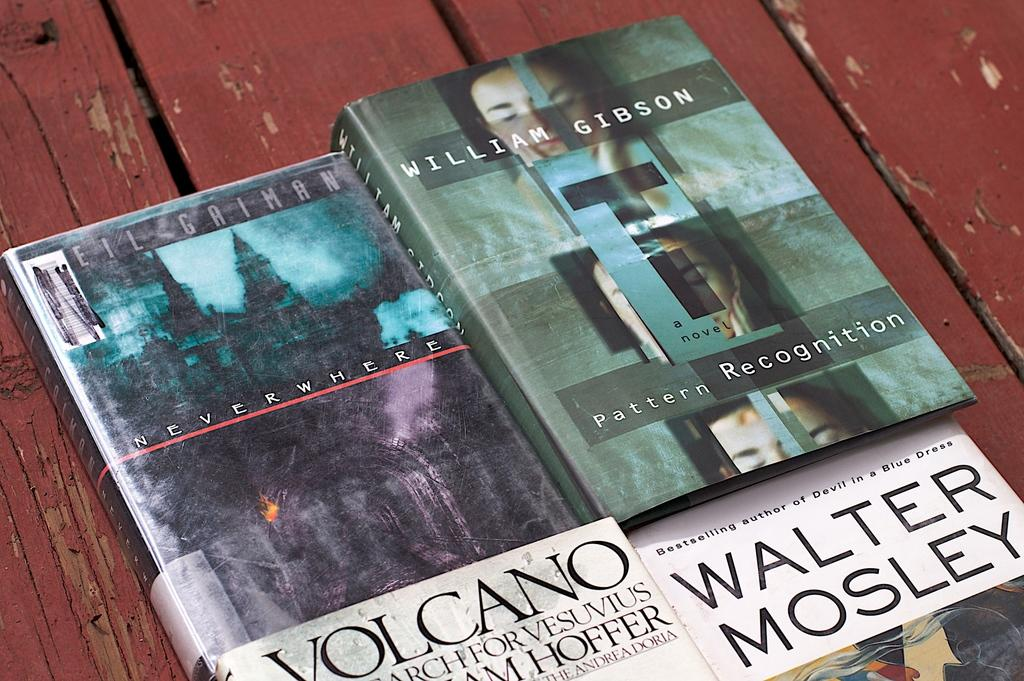Provide a one-sentence caption for the provided image. Book named "Neverwhere" next to a book by William Gibson. 